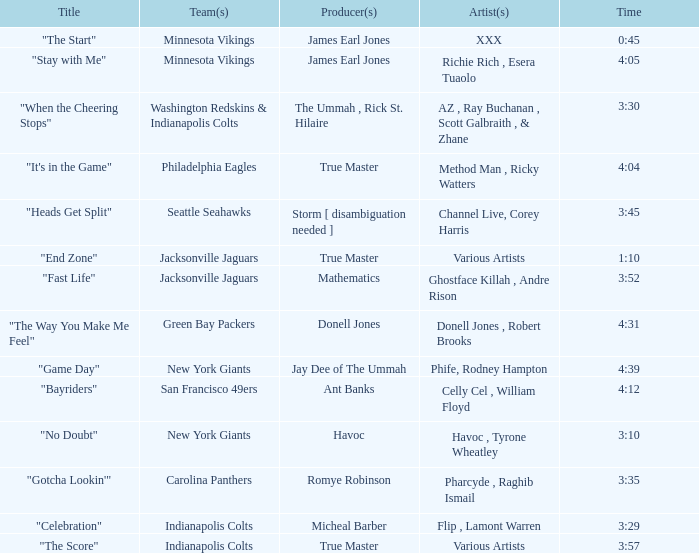Who is the artist of the New York Giants track "No Doubt"? Havoc , Tyrone Wheatley. 